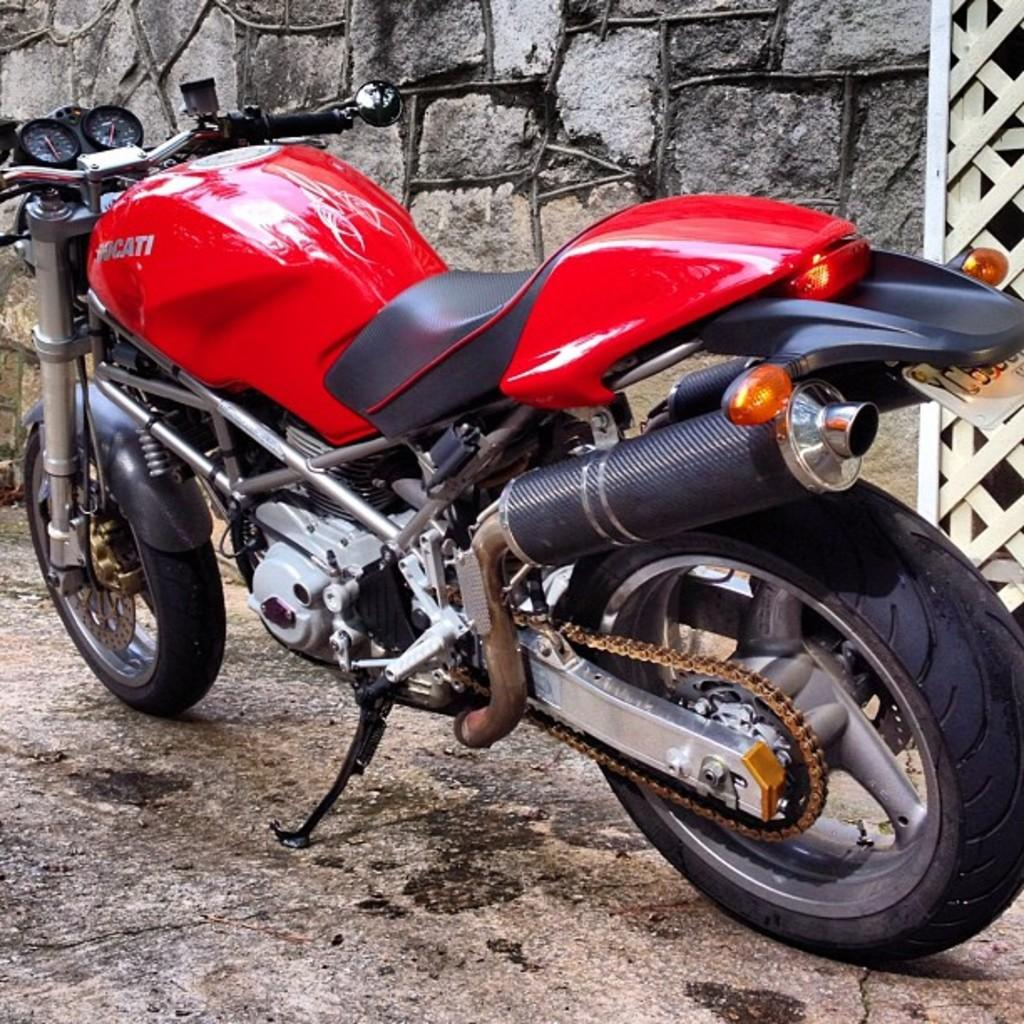Where was the picture taken? The picture was taken outside. What can be seen in the foreground of the image? There is a red color bike in the image. How is the bike positioned in the image? The bike is parked on the ground. What can be seen in the background of the image? There is a stone wall and other objects visible in the background of the image. Can you see a zephyr blowing the bike in the image? There is no zephyr present in the image, and the bike is parked on the ground, so it is not being blown by any wind. 